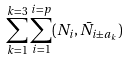<formula> <loc_0><loc_0><loc_500><loc_500>\sum _ { k = 1 } ^ { k = 3 } \sum _ { i = 1 } ^ { i = p } ( N _ { i } , \bar { N } _ { i \pm a _ { k } } )</formula> 